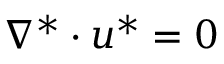<formula> <loc_0><loc_0><loc_500><loc_500>\begin{array} { r } { \nabla ^ { * } \cdot u ^ { * } = 0 } \end{array}</formula> 